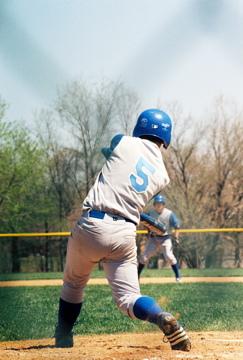How many stripes are on the boy's shoe?
Keep it brief. 3. Did he hit the ball?
Short answer required. No. Where is the blue helmet?
Be succinct. On his head. 